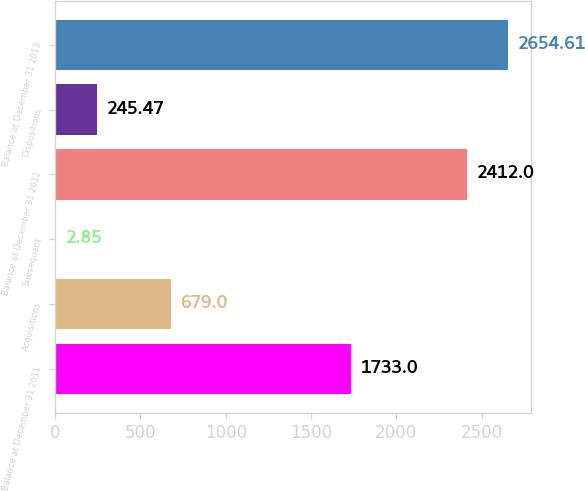Convert chart to OTSL. <chart><loc_0><loc_0><loc_500><loc_500><bar_chart><fcel>Balance at December 31 2011<fcel>Acquisitions<fcel>Subsequent<fcel>Balance at December 31 2012<fcel>Dispositions<fcel>Balance at December 31 2013<nl><fcel>1733<fcel>679<fcel>2.85<fcel>2412<fcel>245.47<fcel>2654.61<nl></chart> 